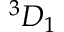<formula> <loc_0><loc_0><loc_500><loc_500>^ { 3 } { D } _ { 1 }</formula> 